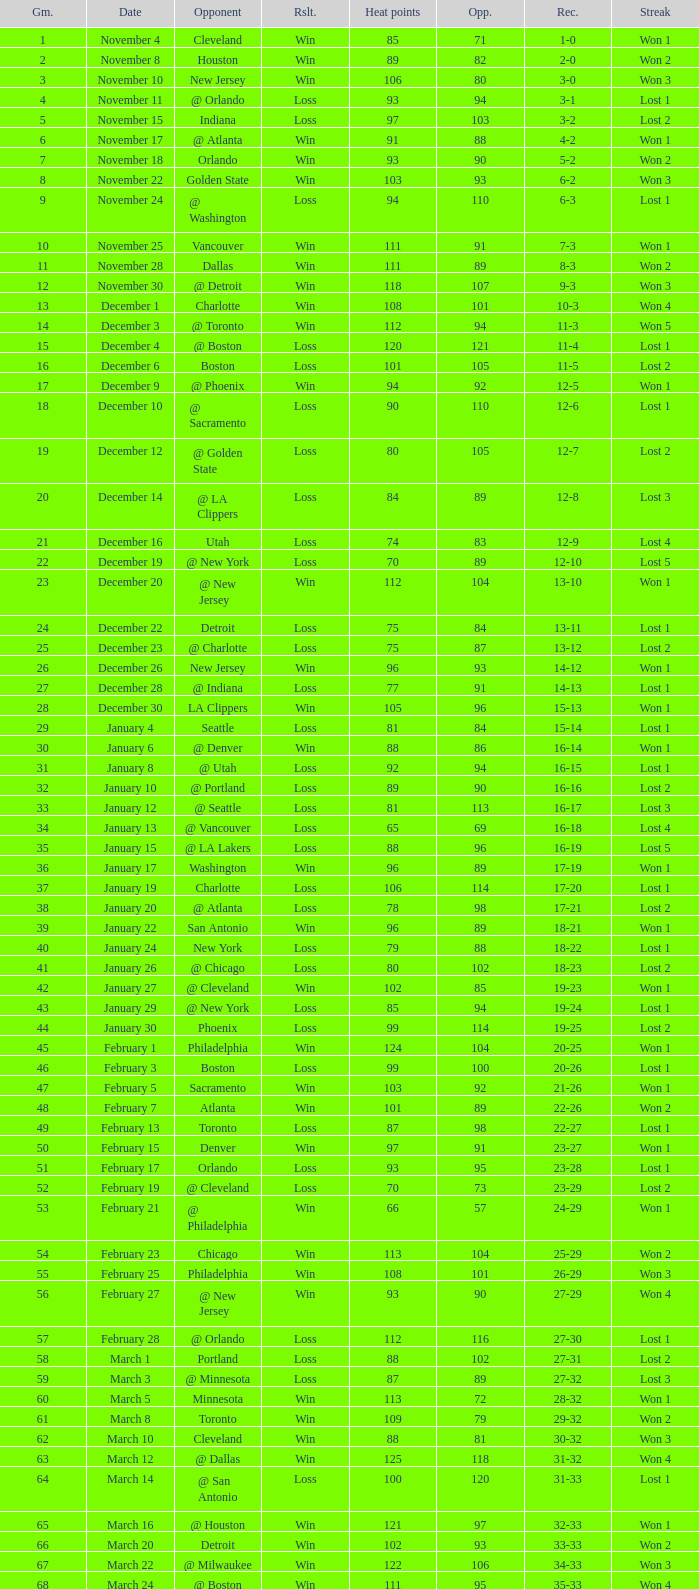What is the average Heat Points, when Result is "Loss", when Game is greater than 72, and when Date is "April 21"? 92.0. 